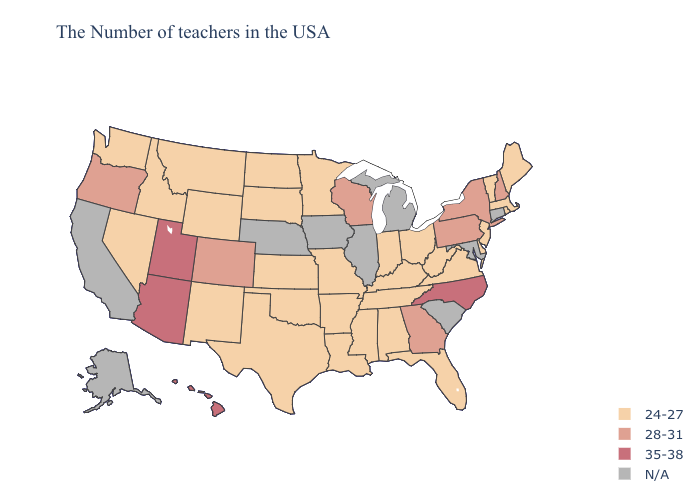What is the value of Wisconsin?
Short answer required. 28-31. What is the value of Utah?
Short answer required. 35-38. What is the lowest value in the West?
Concise answer only. 24-27. Which states hav the highest value in the Northeast?
Give a very brief answer. New Hampshire, New York, Pennsylvania. What is the value of North Dakota?
Answer briefly. 24-27. What is the lowest value in the West?
Concise answer only. 24-27. Which states have the highest value in the USA?
Short answer required. North Carolina, Utah, Arizona, Hawaii. What is the value of Oklahoma?
Write a very short answer. 24-27. How many symbols are there in the legend?
Concise answer only. 4. Name the states that have a value in the range 35-38?
Give a very brief answer. North Carolina, Utah, Arizona, Hawaii. Name the states that have a value in the range 35-38?
Give a very brief answer. North Carolina, Utah, Arizona, Hawaii. Name the states that have a value in the range 24-27?
Short answer required. Maine, Massachusetts, Rhode Island, Vermont, New Jersey, Delaware, Virginia, West Virginia, Ohio, Florida, Kentucky, Indiana, Alabama, Tennessee, Mississippi, Louisiana, Missouri, Arkansas, Minnesota, Kansas, Oklahoma, Texas, South Dakota, North Dakota, Wyoming, New Mexico, Montana, Idaho, Nevada, Washington. Name the states that have a value in the range 28-31?
Short answer required. New Hampshire, New York, Pennsylvania, Georgia, Wisconsin, Colorado, Oregon. 